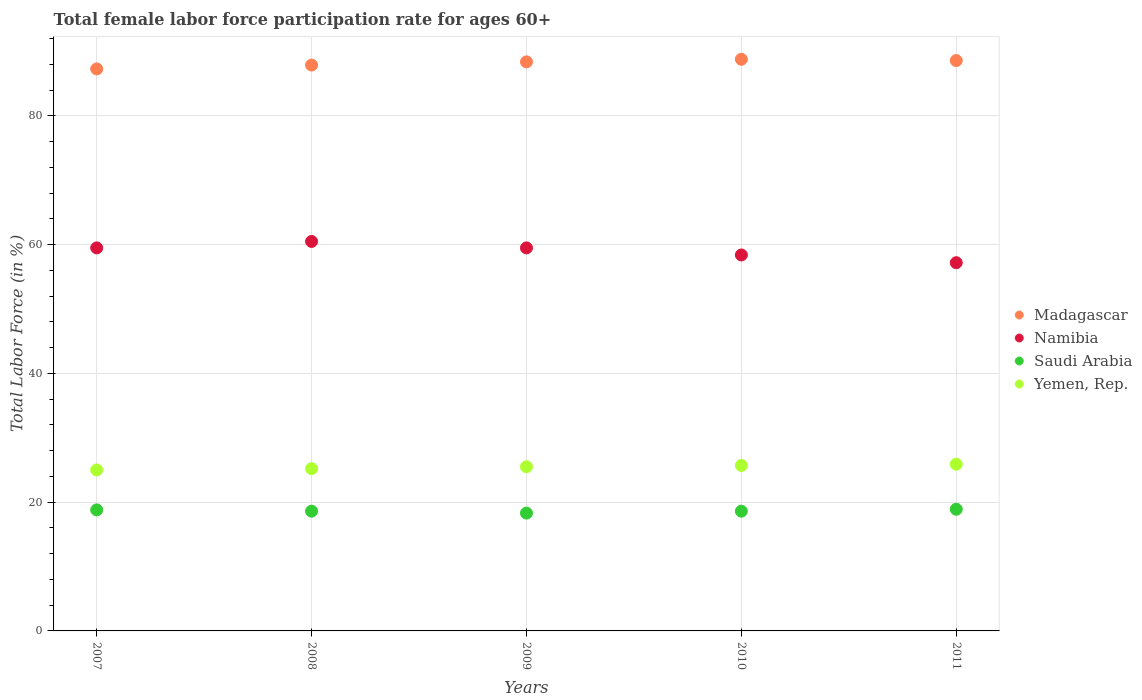Is the number of dotlines equal to the number of legend labels?
Ensure brevity in your answer.  Yes. What is the female labor force participation rate in Namibia in 2011?
Your response must be concise. 57.2. Across all years, what is the maximum female labor force participation rate in Madagascar?
Give a very brief answer. 88.8. Across all years, what is the minimum female labor force participation rate in Namibia?
Your response must be concise. 57.2. In which year was the female labor force participation rate in Madagascar maximum?
Offer a very short reply. 2010. What is the total female labor force participation rate in Madagascar in the graph?
Keep it short and to the point. 441. What is the difference between the female labor force participation rate in Madagascar in 2010 and that in 2011?
Your answer should be very brief. 0.2. What is the difference between the female labor force participation rate in Yemen, Rep. in 2010 and the female labor force participation rate in Madagascar in 2007?
Provide a succinct answer. -61.6. What is the average female labor force participation rate in Saudi Arabia per year?
Provide a short and direct response. 18.64. In the year 2010, what is the difference between the female labor force participation rate in Yemen, Rep. and female labor force participation rate in Madagascar?
Your answer should be very brief. -63.1. What is the ratio of the female labor force participation rate in Madagascar in 2010 to that in 2011?
Offer a very short reply. 1. Is the female labor force participation rate in Saudi Arabia in 2008 less than that in 2010?
Give a very brief answer. No. What is the difference between the highest and the second highest female labor force participation rate in Yemen, Rep.?
Your answer should be compact. 0.2. What is the difference between the highest and the lowest female labor force participation rate in Madagascar?
Keep it short and to the point. 1.5. Is it the case that in every year, the sum of the female labor force participation rate in Madagascar and female labor force participation rate in Namibia  is greater than the sum of female labor force participation rate in Saudi Arabia and female labor force participation rate in Yemen, Rep.?
Your answer should be compact. No. Is it the case that in every year, the sum of the female labor force participation rate in Madagascar and female labor force participation rate in Saudi Arabia  is greater than the female labor force participation rate in Namibia?
Your answer should be very brief. Yes. Is the female labor force participation rate in Namibia strictly greater than the female labor force participation rate in Saudi Arabia over the years?
Your answer should be very brief. Yes. How many years are there in the graph?
Your response must be concise. 5. What is the difference between two consecutive major ticks on the Y-axis?
Offer a very short reply. 20. Are the values on the major ticks of Y-axis written in scientific E-notation?
Offer a terse response. No. Does the graph contain grids?
Provide a succinct answer. Yes. Where does the legend appear in the graph?
Keep it short and to the point. Center right. What is the title of the graph?
Your answer should be compact. Total female labor force participation rate for ages 60+. What is the label or title of the X-axis?
Your answer should be very brief. Years. What is the Total Labor Force (in %) in Madagascar in 2007?
Make the answer very short. 87.3. What is the Total Labor Force (in %) in Namibia in 2007?
Provide a short and direct response. 59.5. What is the Total Labor Force (in %) of Saudi Arabia in 2007?
Provide a short and direct response. 18.8. What is the Total Labor Force (in %) in Yemen, Rep. in 2007?
Provide a short and direct response. 25. What is the Total Labor Force (in %) in Madagascar in 2008?
Ensure brevity in your answer.  87.9. What is the Total Labor Force (in %) in Namibia in 2008?
Offer a terse response. 60.5. What is the Total Labor Force (in %) of Saudi Arabia in 2008?
Ensure brevity in your answer.  18.6. What is the Total Labor Force (in %) of Yemen, Rep. in 2008?
Offer a very short reply. 25.2. What is the Total Labor Force (in %) of Madagascar in 2009?
Provide a succinct answer. 88.4. What is the Total Labor Force (in %) of Namibia in 2009?
Make the answer very short. 59.5. What is the Total Labor Force (in %) in Saudi Arabia in 2009?
Your answer should be very brief. 18.3. What is the Total Labor Force (in %) of Yemen, Rep. in 2009?
Keep it short and to the point. 25.5. What is the Total Labor Force (in %) of Madagascar in 2010?
Your answer should be compact. 88.8. What is the Total Labor Force (in %) of Namibia in 2010?
Your answer should be very brief. 58.4. What is the Total Labor Force (in %) of Saudi Arabia in 2010?
Offer a very short reply. 18.6. What is the Total Labor Force (in %) in Yemen, Rep. in 2010?
Offer a very short reply. 25.7. What is the Total Labor Force (in %) of Madagascar in 2011?
Provide a short and direct response. 88.6. What is the Total Labor Force (in %) in Namibia in 2011?
Offer a terse response. 57.2. What is the Total Labor Force (in %) in Saudi Arabia in 2011?
Your answer should be compact. 18.9. What is the Total Labor Force (in %) of Yemen, Rep. in 2011?
Offer a terse response. 25.9. Across all years, what is the maximum Total Labor Force (in %) of Madagascar?
Offer a terse response. 88.8. Across all years, what is the maximum Total Labor Force (in %) in Namibia?
Provide a short and direct response. 60.5. Across all years, what is the maximum Total Labor Force (in %) of Saudi Arabia?
Provide a succinct answer. 18.9. Across all years, what is the maximum Total Labor Force (in %) of Yemen, Rep.?
Provide a succinct answer. 25.9. Across all years, what is the minimum Total Labor Force (in %) of Madagascar?
Your answer should be compact. 87.3. Across all years, what is the minimum Total Labor Force (in %) of Namibia?
Provide a succinct answer. 57.2. Across all years, what is the minimum Total Labor Force (in %) of Saudi Arabia?
Keep it short and to the point. 18.3. Across all years, what is the minimum Total Labor Force (in %) in Yemen, Rep.?
Your answer should be compact. 25. What is the total Total Labor Force (in %) of Madagascar in the graph?
Your answer should be compact. 441. What is the total Total Labor Force (in %) of Namibia in the graph?
Keep it short and to the point. 295.1. What is the total Total Labor Force (in %) of Saudi Arabia in the graph?
Offer a very short reply. 93.2. What is the total Total Labor Force (in %) in Yemen, Rep. in the graph?
Your answer should be very brief. 127.3. What is the difference between the Total Labor Force (in %) of Namibia in 2007 and that in 2008?
Make the answer very short. -1. What is the difference between the Total Labor Force (in %) of Saudi Arabia in 2007 and that in 2008?
Your answer should be very brief. 0.2. What is the difference between the Total Labor Force (in %) in Yemen, Rep. in 2007 and that in 2009?
Provide a short and direct response. -0.5. What is the difference between the Total Labor Force (in %) of Namibia in 2007 and that in 2010?
Your answer should be compact. 1.1. What is the difference between the Total Labor Force (in %) in Madagascar in 2007 and that in 2011?
Give a very brief answer. -1.3. What is the difference between the Total Labor Force (in %) in Saudi Arabia in 2007 and that in 2011?
Offer a terse response. -0.1. What is the difference between the Total Labor Force (in %) in Yemen, Rep. in 2007 and that in 2011?
Provide a succinct answer. -0.9. What is the difference between the Total Labor Force (in %) of Namibia in 2008 and that in 2010?
Ensure brevity in your answer.  2.1. What is the difference between the Total Labor Force (in %) in Saudi Arabia in 2008 and that in 2010?
Your answer should be very brief. 0. What is the difference between the Total Labor Force (in %) of Madagascar in 2008 and that in 2011?
Your response must be concise. -0.7. What is the difference between the Total Labor Force (in %) in Saudi Arabia in 2008 and that in 2011?
Keep it short and to the point. -0.3. What is the difference between the Total Labor Force (in %) in Madagascar in 2009 and that in 2010?
Your answer should be very brief. -0.4. What is the difference between the Total Labor Force (in %) in Namibia in 2009 and that in 2010?
Your response must be concise. 1.1. What is the difference between the Total Labor Force (in %) of Saudi Arabia in 2010 and that in 2011?
Ensure brevity in your answer.  -0.3. What is the difference between the Total Labor Force (in %) in Madagascar in 2007 and the Total Labor Force (in %) in Namibia in 2008?
Your answer should be very brief. 26.8. What is the difference between the Total Labor Force (in %) in Madagascar in 2007 and the Total Labor Force (in %) in Saudi Arabia in 2008?
Make the answer very short. 68.7. What is the difference between the Total Labor Force (in %) in Madagascar in 2007 and the Total Labor Force (in %) in Yemen, Rep. in 2008?
Your answer should be very brief. 62.1. What is the difference between the Total Labor Force (in %) of Namibia in 2007 and the Total Labor Force (in %) of Saudi Arabia in 2008?
Give a very brief answer. 40.9. What is the difference between the Total Labor Force (in %) of Namibia in 2007 and the Total Labor Force (in %) of Yemen, Rep. in 2008?
Offer a very short reply. 34.3. What is the difference between the Total Labor Force (in %) of Madagascar in 2007 and the Total Labor Force (in %) of Namibia in 2009?
Ensure brevity in your answer.  27.8. What is the difference between the Total Labor Force (in %) of Madagascar in 2007 and the Total Labor Force (in %) of Saudi Arabia in 2009?
Give a very brief answer. 69. What is the difference between the Total Labor Force (in %) of Madagascar in 2007 and the Total Labor Force (in %) of Yemen, Rep. in 2009?
Your response must be concise. 61.8. What is the difference between the Total Labor Force (in %) of Namibia in 2007 and the Total Labor Force (in %) of Saudi Arabia in 2009?
Provide a succinct answer. 41.2. What is the difference between the Total Labor Force (in %) in Namibia in 2007 and the Total Labor Force (in %) in Yemen, Rep. in 2009?
Keep it short and to the point. 34. What is the difference between the Total Labor Force (in %) of Madagascar in 2007 and the Total Labor Force (in %) of Namibia in 2010?
Your answer should be compact. 28.9. What is the difference between the Total Labor Force (in %) in Madagascar in 2007 and the Total Labor Force (in %) in Saudi Arabia in 2010?
Make the answer very short. 68.7. What is the difference between the Total Labor Force (in %) of Madagascar in 2007 and the Total Labor Force (in %) of Yemen, Rep. in 2010?
Give a very brief answer. 61.6. What is the difference between the Total Labor Force (in %) of Namibia in 2007 and the Total Labor Force (in %) of Saudi Arabia in 2010?
Give a very brief answer. 40.9. What is the difference between the Total Labor Force (in %) of Namibia in 2007 and the Total Labor Force (in %) of Yemen, Rep. in 2010?
Make the answer very short. 33.8. What is the difference between the Total Labor Force (in %) of Saudi Arabia in 2007 and the Total Labor Force (in %) of Yemen, Rep. in 2010?
Your answer should be very brief. -6.9. What is the difference between the Total Labor Force (in %) of Madagascar in 2007 and the Total Labor Force (in %) of Namibia in 2011?
Give a very brief answer. 30.1. What is the difference between the Total Labor Force (in %) of Madagascar in 2007 and the Total Labor Force (in %) of Saudi Arabia in 2011?
Keep it short and to the point. 68.4. What is the difference between the Total Labor Force (in %) in Madagascar in 2007 and the Total Labor Force (in %) in Yemen, Rep. in 2011?
Make the answer very short. 61.4. What is the difference between the Total Labor Force (in %) in Namibia in 2007 and the Total Labor Force (in %) in Saudi Arabia in 2011?
Make the answer very short. 40.6. What is the difference between the Total Labor Force (in %) in Namibia in 2007 and the Total Labor Force (in %) in Yemen, Rep. in 2011?
Ensure brevity in your answer.  33.6. What is the difference between the Total Labor Force (in %) in Madagascar in 2008 and the Total Labor Force (in %) in Namibia in 2009?
Ensure brevity in your answer.  28.4. What is the difference between the Total Labor Force (in %) in Madagascar in 2008 and the Total Labor Force (in %) in Saudi Arabia in 2009?
Offer a terse response. 69.6. What is the difference between the Total Labor Force (in %) in Madagascar in 2008 and the Total Labor Force (in %) in Yemen, Rep. in 2009?
Your answer should be compact. 62.4. What is the difference between the Total Labor Force (in %) of Namibia in 2008 and the Total Labor Force (in %) of Saudi Arabia in 2009?
Make the answer very short. 42.2. What is the difference between the Total Labor Force (in %) in Saudi Arabia in 2008 and the Total Labor Force (in %) in Yemen, Rep. in 2009?
Make the answer very short. -6.9. What is the difference between the Total Labor Force (in %) of Madagascar in 2008 and the Total Labor Force (in %) of Namibia in 2010?
Provide a short and direct response. 29.5. What is the difference between the Total Labor Force (in %) in Madagascar in 2008 and the Total Labor Force (in %) in Saudi Arabia in 2010?
Your answer should be very brief. 69.3. What is the difference between the Total Labor Force (in %) in Madagascar in 2008 and the Total Labor Force (in %) in Yemen, Rep. in 2010?
Your answer should be very brief. 62.2. What is the difference between the Total Labor Force (in %) of Namibia in 2008 and the Total Labor Force (in %) of Saudi Arabia in 2010?
Your answer should be compact. 41.9. What is the difference between the Total Labor Force (in %) of Namibia in 2008 and the Total Labor Force (in %) of Yemen, Rep. in 2010?
Your response must be concise. 34.8. What is the difference between the Total Labor Force (in %) of Saudi Arabia in 2008 and the Total Labor Force (in %) of Yemen, Rep. in 2010?
Your answer should be very brief. -7.1. What is the difference between the Total Labor Force (in %) of Madagascar in 2008 and the Total Labor Force (in %) of Namibia in 2011?
Offer a terse response. 30.7. What is the difference between the Total Labor Force (in %) in Madagascar in 2008 and the Total Labor Force (in %) in Saudi Arabia in 2011?
Provide a short and direct response. 69. What is the difference between the Total Labor Force (in %) of Madagascar in 2008 and the Total Labor Force (in %) of Yemen, Rep. in 2011?
Provide a short and direct response. 62. What is the difference between the Total Labor Force (in %) in Namibia in 2008 and the Total Labor Force (in %) in Saudi Arabia in 2011?
Ensure brevity in your answer.  41.6. What is the difference between the Total Labor Force (in %) in Namibia in 2008 and the Total Labor Force (in %) in Yemen, Rep. in 2011?
Provide a succinct answer. 34.6. What is the difference between the Total Labor Force (in %) in Madagascar in 2009 and the Total Labor Force (in %) in Saudi Arabia in 2010?
Offer a very short reply. 69.8. What is the difference between the Total Labor Force (in %) of Madagascar in 2009 and the Total Labor Force (in %) of Yemen, Rep. in 2010?
Your response must be concise. 62.7. What is the difference between the Total Labor Force (in %) in Namibia in 2009 and the Total Labor Force (in %) in Saudi Arabia in 2010?
Keep it short and to the point. 40.9. What is the difference between the Total Labor Force (in %) in Namibia in 2009 and the Total Labor Force (in %) in Yemen, Rep. in 2010?
Provide a succinct answer. 33.8. What is the difference between the Total Labor Force (in %) in Madagascar in 2009 and the Total Labor Force (in %) in Namibia in 2011?
Offer a terse response. 31.2. What is the difference between the Total Labor Force (in %) in Madagascar in 2009 and the Total Labor Force (in %) in Saudi Arabia in 2011?
Make the answer very short. 69.5. What is the difference between the Total Labor Force (in %) of Madagascar in 2009 and the Total Labor Force (in %) of Yemen, Rep. in 2011?
Keep it short and to the point. 62.5. What is the difference between the Total Labor Force (in %) of Namibia in 2009 and the Total Labor Force (in %) of Saudi Arabia in 2011?
Make the answer very short. 40.6. What is the difference between the Total Labor Force (in %) in Namibia in 2009 and the Total Labor Force (in %) in Yemen, Rep. in 2011?
Offer a terse response. 33.6. What is the difference between the Total Labor Force (in %) of Madagascar in 2010 and the Total Labor Force (in %) of Namibia in 2011?
Your answer should be compact. 31.6. What is the difference between the Total Labor Force (in %) in Madagascar in 2010 and the Total Labor Force (in %) in Saudi Arabia in 2011?
Your answer should be compact. 69.9. What is the difference between the Total Labor Force (in %) in Madagascar in 2010 and the Total Labor Force (in %) in Yemen, Rep. in 2011?
Provide a short and direct response. 62.9. What is the difference between the Total Labor Force (in %) of Namibia in 2010 and the Total Labor Force (in %) of Saudi Arabia in 2011?
Provide a short and direct response. 39.5. What is the difference between the Total Labor Force (in %) in Namibia in 2010 and the Total Labor Force (in %) in Yemen, Rep. in 2011?
Provide a short and direct response. 32.5. What is the difference between the Total Labor Force (in %) of Saudi Arabia in 2010 and the Total Labor Force (in %) of Yemen, Rep. in 2011?
Offer a very short reply. -7.3. What is the average Total Labor Force (in %) of Madagascar per year?
Offer a very short reply. 88.2. What is the average Total Labor Force (in %) in Namibia per year?
Your answer should be very brief. 59.02. What is the average Total Labor Force (in %) in Saudi Arabia per year?
Offer a terse response. 18.64. What is the average Total Labor Force (in %) in Yemen, Rep. per year?
Your answer should be very brief. 25.46. In the year 2007, what is the difference between the Total Labor Force (in %) in Madagascar and Total Labor Force (in %) in Namibia?
Offer a terse response. 27.8. In the year 2007, what is the difference between the Total Labor Force (in %) of Madagascar and Total Labor Force (in %) of Saudi Arabia?
Make the answer very short. 68.5. In the year 2007, what is the difference between the Total Labor Force (in %) of Madagascar and Total Labor Force (in %) of Yemen, Rep.?
Provide a short and direct response. 62.3. In the year 2007, what is the difference between the Total Labor Force (in %) of Namibia and Total Labor Force (in %) of Saudi Arabia?
Keep it short and to the point. 40.7. In the year 2007, what is the difference between the Total Labor Force (in %) in Namibia and Total Labor Force (in %) in Yemen, Rep.?
Make the answer very short. 34.5. In the year 2008, what is the difference between the Total Labor Force (in %) in Madagascar and Total Labor Force (in %) in Namibia?
Make the answer very short. 27.4. In the year 2008, what is the difference between the Total Labor Force (in %) in Madagascar and Total Labor Force (in %) in Saudi Arabia?
Provide a short and direct response. 69.3. In the year 2008, what is the difference between the Total Labor Force (in %) in Madagascar and Total Labor Force (in %) in Yemen, Rep.?
Offer a very short reply. 62.7. In the year 2008, what is the difference between the Total Labor Force (in %) of Namibia and Total Labor Force (in %) of Saudi Arabia?
Offer a terse response. 41.9. In the year 2008, what is the difference between the Total Labor Force (in %) of Namibia and Total Labor Force (in %) of Yemen, Rep.?
Make the answer very short. 35.3. In the year 2009, what is the difference between the Total Labor Force (in %) of Madagascar and Total Labor Force (in %) of Namibia?
Keep it short and to the point. 28.9. In the year 2009, what is the difference between the Total Labor Force (in %) of Madagascar and Total Labor Force (in %) of Saudi Arabia?
Offer a very short reply. 70.1. In the year 2009, what is the difference between the Total Labor Force (in %) of Madagascar and Total Labor Force (in %) of Yemen, Rep.?
Your response must be concise. 62.9. In the year 2009, what is the difference between the Total Labor Force (in %) in Namibia and Total Labor Force (in %) in Saudi Arabia?
Give a very brief answer. 41.2. In the year 2009, what is the difference between the Total Labor Force (in %) of Namibia and Total Labor Force (in %) of Yemen, Rep.?
Provide a succinct answer. 34. In the year 2010, what is the difference between the Total Labor Force (in %) in Madagascar and Total Labor Force (in %) in Namibia?
Offer a very short reply. 30.4. In the year 2010, what is the difference between the Total Labor Force (in %) of Madagascar and Total Labor Force (in %) of Saudi Arabia?
Your answer should be compact. 70.2. In the year 2010, what is the difference between the Total Labor Force (in %) of Madagascar and Total Labor Force (in %) of Yemen, Rep.?
Your answer should be compact. 63.1. In the year 2010, what is the difference between the Total Labor Force (in %) of Namibia and Total Labor Force (in %) of Saudi Arabia?
Your response must be concise. 39.8. In the year 2010, what is the difference between the Total Labor Force (in %) in Namibia and Total Labor Force (in %) in Yemen, Rep.?
Provide a succinct answer. 32.7. In the year 2011, what is the difference between the Total Labor Force (in %) of Madagascar and Total Labor Force (in %) of Namibia?
Keep it short and to the point. 31.4. In the year 2011, what is the difference between the Total Labor Force (in %) of Madagascar and Total Labor Force (in %) of Saudi Arabia?
Keep it short and to the point. 69.7. In the year 2011, what is the difference between the Total Labor Force (in %) of Madagascar and Total Labor Force (in %) of Yemen, Rep.?
Make the answer very short. 62.7. In the year 2011, what is the difference between the Total Labor Force (in %) in Namibia and Total Labor Force (in %) in Saudi Arabia?
Your answer should be very brief. 38.3. In the year 2011, what is the difference between the Total Labor Force (in %) of Namibia and Total Labor Force (in %) of Yemen, Rep.?
Offer a terse response. 31.3. In the year 2011, what is the difference between the Total Labor Force (in %) in Saudi Arabia and Total Labor Force (in %) in Yemen, Rep.?
Give a very brief answer. -7. What is the ratio of the Total Labor Force (in %) of Madagascar in 2007 to that in 2008?
Offer a very short reply. 0.99. What is the ratio of the Total Labor Force (in %) in Namibia in 2007 to that in 2008?
Offer a terse response. 0.98. What is the ratio of the Total Labor Force (in %) of Saudi Arabia in 2007 to that in 2008?
Offer a terse response. 1.01. What is the ratio of the Total Labor Force (in %) in Yemen, Rep. in 2007 to that in 2008?
Offer a very short reply. 0.99. What is the ratio of the Total Labor Force (in %) in Madagascar in 2007 to that in 2009?
Offer a terse response. 0.99. What is the ratio of the Total Labor Force (in %) of Saudi Arabia in 2007 to that in 2009?
Provide a short and direct response. 1.03. What is the ratio of the Total Labor Force (in %) of Yemen, Rep. in 2007 to that in 2009?
Ensure brevity in your answer.  0.98. What is the ratio of the Total Labor Force (in %) in Madagascar in 2007 to that in 2010?
Your answer should be very brief. 0.98. What is the ratio of the Total Labor Force (in %) in Namibia in 2007 to that in 2010?
Provide a succinct answer. 1.02. What is the ratio of the Total Labor Force (in %) of Saudi Arabia in 2007 to that in 2010?
Keep it short and to the point. 1.01. What is the ratio of the Total Labor Force (in %) of Yemen, Rep. in 2007 to that in 2010?
Your answer should be compact. 0.97. What is the ratio of the Total Labor Force (in %) of Madagascar in 2007 to that in 2011?
Ensure brevity in your answer.  0.99. What is the ratio of the Total Labor Force (in %) of Namibia in 2007 to that in 2011?
Provide a short and direct response. 1.04. What is the ratio of the Total Labor Force (in %) of Yemen, Rep. in 2007 to that in 2011?
Offer a very short reply. 0.97. What is the ratio of the Total Labor Force (in %) in Namibia in 2008 to that in 2009?
Your response must be concise. 1.02. What is the ratio of the Total Labor Force (in %) of Saudi Arabia in 2008 to that in 2009?
Give a very brief answer. 1.02. What is the ratio of the Total Labor Force (in %) in Namibia in 2008 to that in 2010?
Offer a very short reply. 1.04. What is the ratio of the Total Labor Force (in %) in Yemen, Rep. in 2008 to that in 2010?
Provide a short and direct response. 0.98. What is the ratio of the Total Labor Force (in %) in Namibia in 2008 to that in 2011?
Give a very brief answer. 1.06. What is the ratio of the Total Labor Force (in %) in Saudi Arabia in 2008 to that in 2011?
Offer a very short reply. 0.98. What is the ratio of the Total Labor Force (in %) in Namibia in 2009 to that in 2010?
Make the answer very short. 1.02. What is the ratio of the Total Labor Force (in %) in Saudi Arabia in 2009 to that in 2010?
Make the answer very short. 0.98. What is the ratio of the Total Labor Force (in %) of Madagascar in 2009 to that in 2011?
Provide a short and direct response. 1. What is the ratio of the Total Labor Force (in %) of Namibia in 2009 to that in 2011?
Provide a succinct answer. 1.04. What is the ratio of the Total Labor Force (in %) of Saudi Arabia in 2009 to that in 2011?
Your response must be concise. 0.97. What is the ratio of the Total Labor Force (in %) in Yemen, Rep. in 2009 to that in 2011?
Ensure brevity in your answer.  0.98. What is the ratio of the Total Labor Force (in %) in Madagascar in 2010 to that in 2011?
Your response must be concise. 1. What is the ratio of the Total Labor Force (in %) of Namibia in 2010 to that in 2011?
Offer a terse response. 1.02. What is the ratio of the Total Labor Force (in %) in Saudi Arabia in 2010 to that in 2011?
Ensure brevity in your answer.  0.98. What is the ratio of the Total Labor Force (in %) in Yemen, Rep. in 2010 to that in 2011?
Provide a succinct answer. 0.99. What is the difference between the highest and the second highest Total Labor Force (in %) of Madagascar?
Ensure brevity in your answer.  0.2. What is the difference between the highest and the second highest Total Labor Force (in %) of Saudi Arabia?
Provide a short and direct response. 0.1. What is the difference between the highest and the lowest Total Labor Force (in %) in Madagascar?
Keep it short and to the point. 1.5. What is the difference between the highest and the lowest Total Labor Force (in %) in Saudi Arabia?
Make the answer very short. 0.6. 